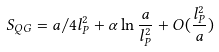Convert formula to latex. <formula><loc_0><loc_0><loc_500><loc_500>S _ { Q G } = a / 4 l _ { P } ^ { 2 } + \alpha \ln \frac { a } { l _ { P } ^ { 2 } } + O ( \frac { l _ { P } ^ { 2 } } { a } )</formula> 